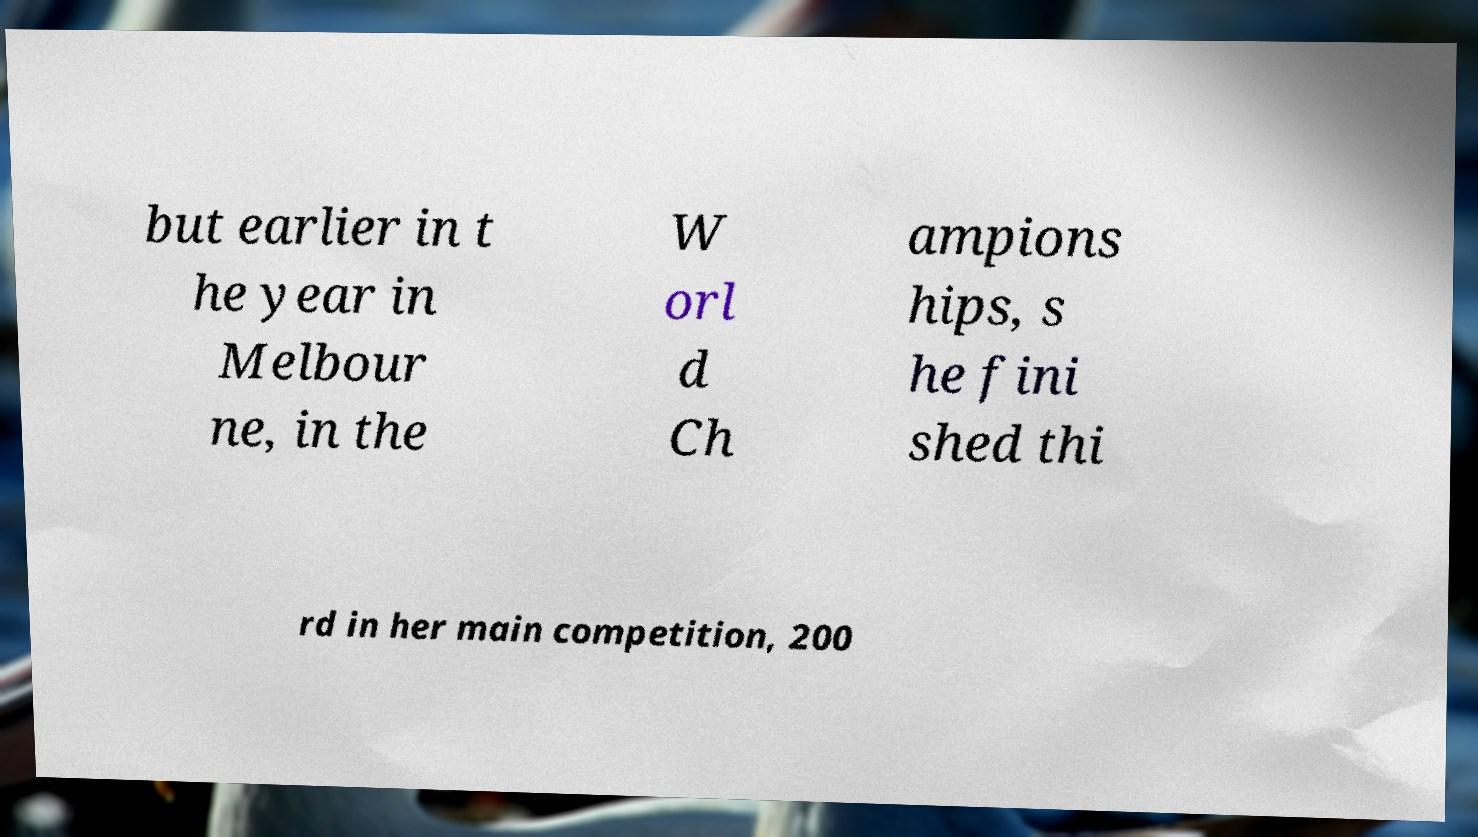For documentation purposes, I need the text within this image transcribed. Could you provide that? but earlier in t he year in Melbour ne, in the W orl d Ch ampions hips, s he fini shed thi rd in her main competition, 200 